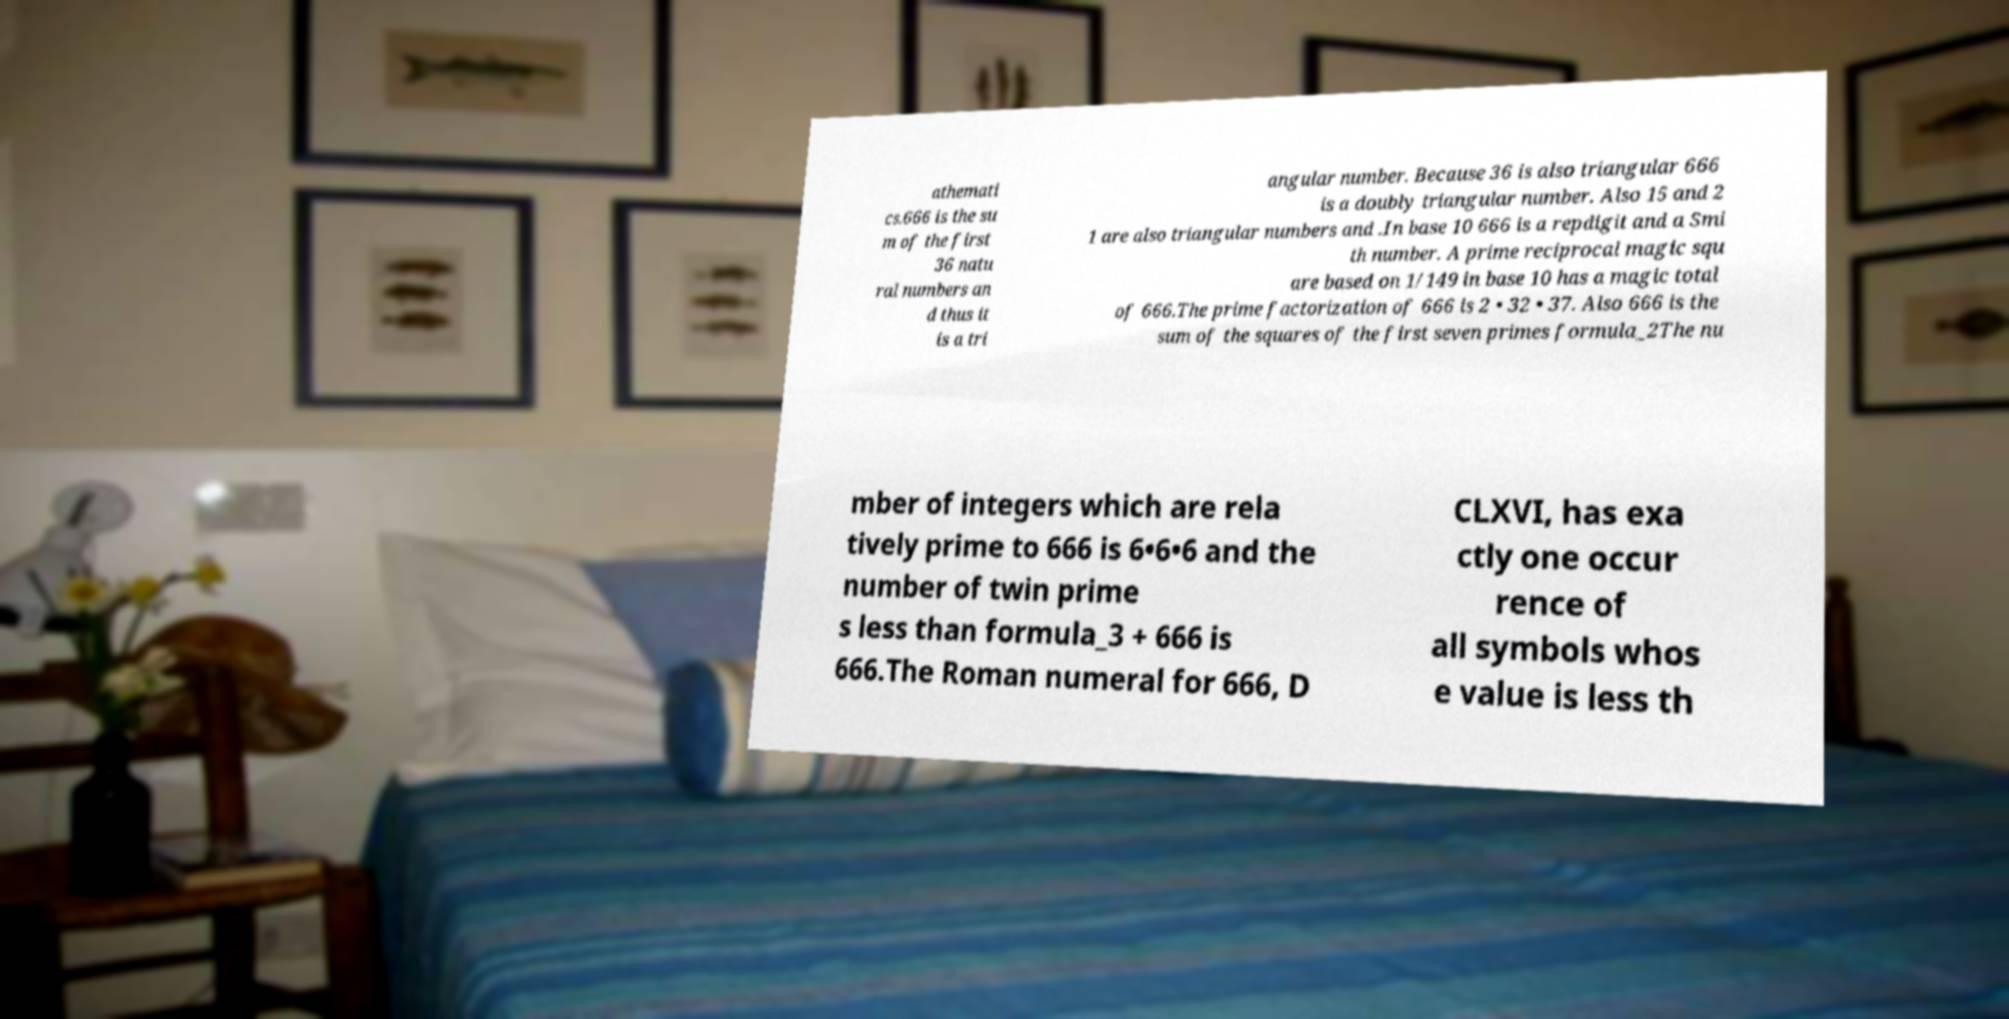Could you extract and type out the text from this image? athemati cs.666 is the su m of the first 36 natu ral numbers an d thus it is a tri angular number. Because 36 is also triangular 666 is a doubly triangular number. Also 15 and 2 1 are also triangular numbers and .In base 10 666 is a repdigit and a Smi th number. A prime reciprocal magic squ are based on 1/149 in base 10 has a magic total of 666.The prime factorization of 666 is 2 • 32 • 37. Also 666 is the sum of the squares of the first seven primes formula_2The nu mber of integers which are rela tively prime to 666 is 6•6•6 and the number of twin prime s less than formula_3 + 666 is 666.The Roman numeral for 666, D CLXVI, has exa ctly one occur rence of all symbols whos e value is less th 